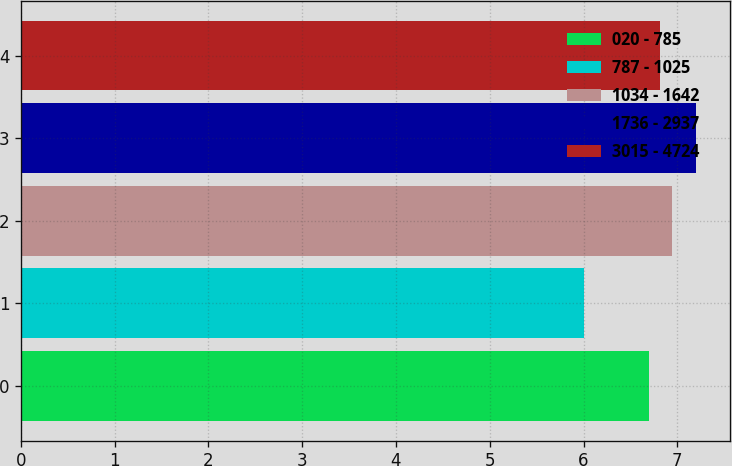<chart> <loc_0><loc_0><loc_500><loc_500><bar_chart><fcel>020 - 785<fcel>787 - 1025<fcel>1034 - 1642<fcel>1736 - 2937<fcel>3015 - 4724<nl><fcel>6.7<fcel>6<fcel>6.94<fcel>7.2<fcel>6.82<nl></chart> 